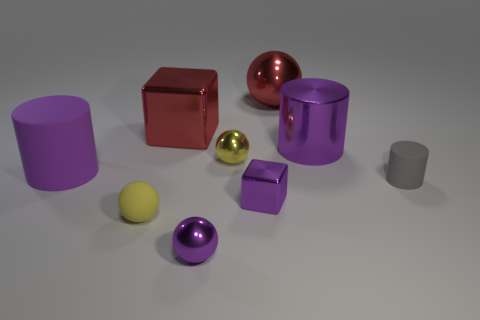Subtract all cyan spheres. Subtract all gray cylinders. How many spheres are left? 4 Add 1 red things. How many objects exist? 10 Subtract all spheres. How many objects are left? 5 Add 9 small purple metal cubes. How many small purple metal cubes exist? 10 Subtract 0 blue spheres. How many objects are left? 9 Subtract all red metal cylinders. Subtract all purple metal blocks. How many objects are left? 8 Add 7 big red metallic objects. How many big red metallic objects are left? 9 